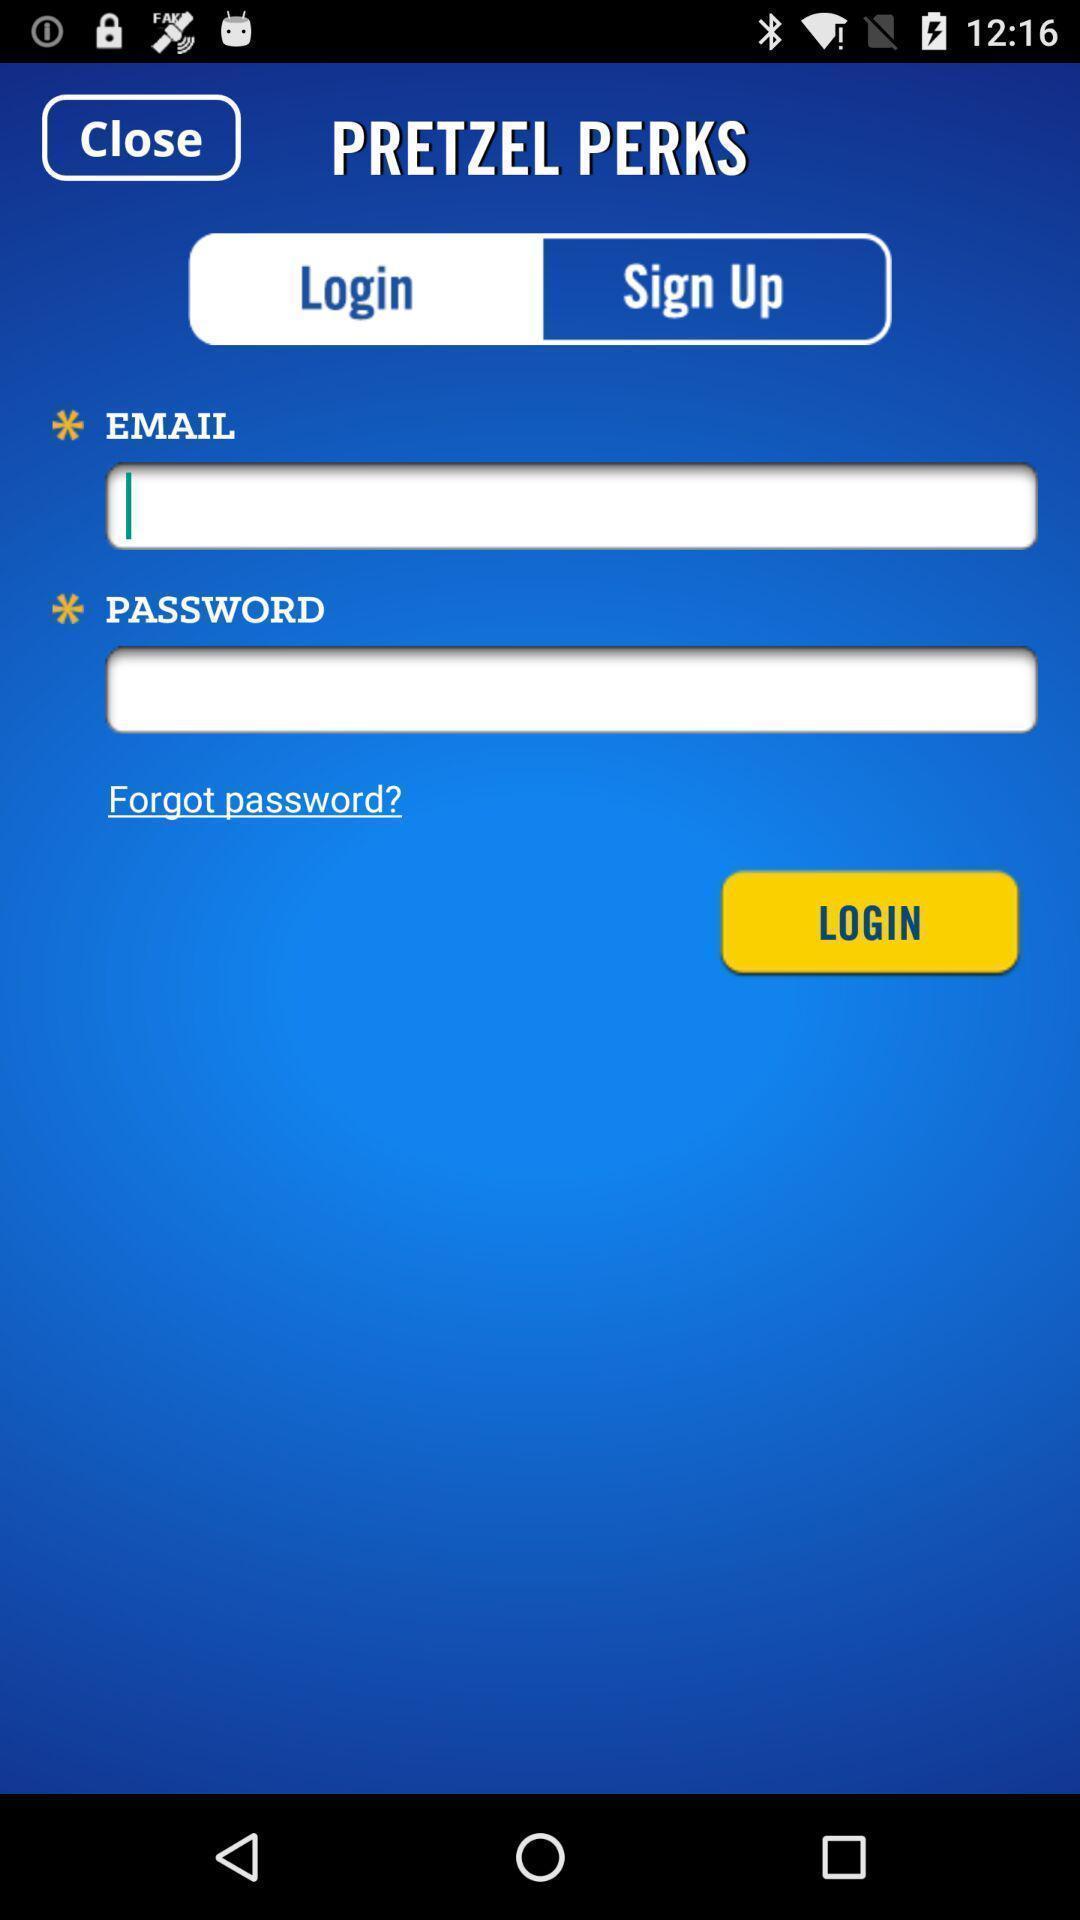Provide a textual representation of this image. Login page. 